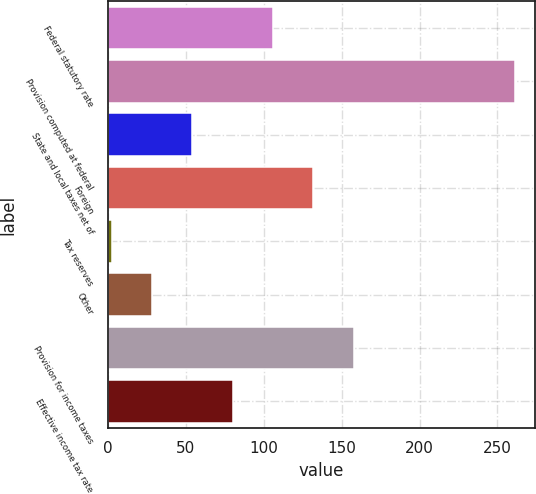Convert chart. <chart><loc_0><loc_0><loc_500><loc_500><bar_chart><fcel>Federal statutory rate<fcel>Provision computed at federal<fcel>State and local taxes net of<fcel>Foreign<fcel>Tax reserves<fcel>Other<fcel>Provision for income taxes<fcel>Effective income tax rate<nl><fcel>106.02<fcel>261.3<fcel>54.26<fcel>131.9<fcel>2.5<fcel>28.38<fcel>157.78<fcel>80.14<nl></chart> 